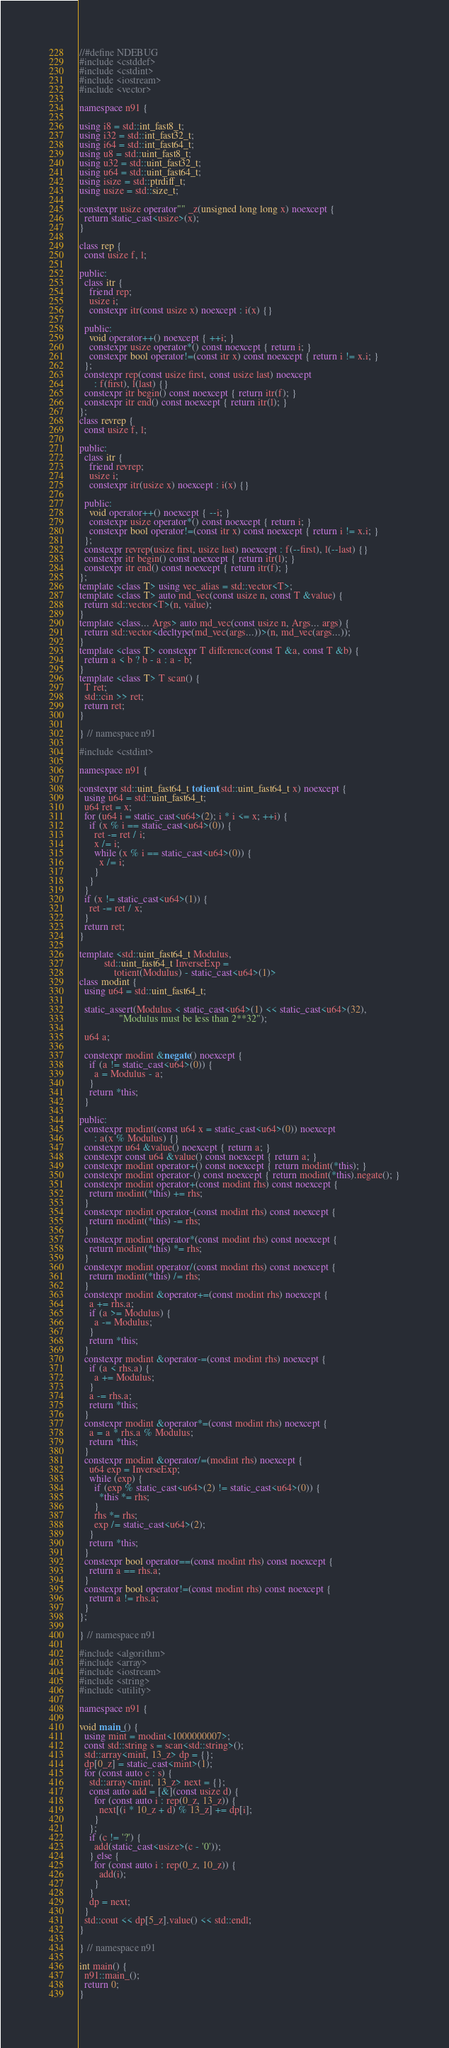Convert code to text. <code><loc_0><loc_0><loc_500><loc_500><_C++_>//#define NDEBUG
#include <cstddef>
#include <cstdint>
#include <iostream>
#include <vector>

namespace n91 {

using i8 = std::int_fast8_t;
using i32 = std::int_fast32_t;
using i64 = std::int_fast64_t;
using u8 = std::uint_fast8_t;
using u32 = std::uint_fast32_t;
using u64 = std::uint_fast64_t;
using isize = std::ptrdiff_t;
using usize = std::size_t;

constexpr usize operator"" _z(unsigned long long x) noexcept {
  return static_cast<usize>(x);
}

class rep {
  const usize f, l;

public:
  class itr {
    friend rep;
    usize i;
    constexpr itr(const usize x) noexcept : i(x) {}

  public:
    void operator++() noexcept { ++i; }
    constexpr usize operator*() const noexcept { return i; }
    constexpr bool operator!=(const itr x) const noexcept { return i != x.i; }
  };
  constexpr rep(const usize first, const usize last) noexcept
      : f(first), l(last) {}
  constexpr itr begin() const noexcept { return itr(f); }
  constexpr itr end() const noexcept { return itr(l); }
};
class revrep {
  const usize f, l;

public:
  class itr {
    friend revrep;
    usize i;
    constexpr itr(usize x) noexcept : i(x) {}

  public:
    void operator++() noexcept { --i; }
    constexpr usize operator*() const noexcept { return i; }
    constexpr bool operator!=(const itr x) const noexcept { return i != x.i; }
  };
  constexpr revrep(usize first, usize last) noexcept : f(--first), l(--last) {}
  constexpr itr begin() const noexcept { return itr(l); }
  constexpr itr end() const noexcept { return itr(f); }
};
template <class T> using vec_alias = std::vector<T>;
template <class T> auto md_vec(const usize n, const T &value) {
  return std::vector<T>(n, value);
}
template <class... Args> auto md_vec(const usize n, Args... args) {
  return std::vector<decltype(md_vec(args...))>(n, md_vec(args...));
}
template <class T> constexpr T difference(const T &a, const T &b) {
  return a < b ? b - a : a - b;
}
template <class T> T scan() {
  T ret;
  std::cin >> ret;
  return ret;
}

} // namespace n91

#include <cstdint>

namespace n91 {

constexpr std::uint_fast64_t totient(std::uint_fast64_t x) noexcept {
  using u64 = std::uint_fast64_t;
  u64 ret = x;
  for (u64 i = static_cast<u64>(2); i * i <= x; ++i) {
    if (x % i == static_cast<u64>(0)) {
      ret -= ret / i;
      x /= i;
      while (x % i == static_cast<u64>(0)) {
        x /= i;
      }
    }
  }
  if (x != static_cast<u64>(1)) {
    ret -= ret / x;
  }
  return ret;
}

template <std::uint_fast64_t Modulus,
          std::uint_fast64_t InverseExp =
              totient(Modulus) - static_cast<u64>(1)>
class modint {
  using u64 = std::uint_fast64_t;

  static_assert(Modulus < static_cast<u64>(1) << static_cast<u64>(32),
                "Modulus must be less than 2**32");

  u64 a;

  constexpr modint &negate() noexcept {
    if (a != static_cast<u64>(0)) {
      a = Modulus - a;
    }
    return *this;
  }

public:
  constexpr modint(const u64 x = static_cast<u64>(0)) noexcept
      : a(x % Modulus) {}
  constexpr u64 &value() noexcept { return a; }
  constexpr const u64 &value() const noexcept { return a; }
  constexpr modint operator+() const noexcept { return modint(*this); }
  constexpr modint operator-() const noexcept { return modint(*this).negate(); }
  constexpr modint operator+(const modint rhs) const noexcept {
    return modint(*this) += rhs;
  }
  constexpr modint operator-(const modint rhs) const noexcept {
    return modint(*this) -= rhs;
  }
  constexpr modint operator*(const modint rhs) const noexcept {
    return modint(*this) *= rhs;
  }
  constexpr modint operator/(const modint rhs) const noexcept {
    return modint(*this) /= rhs;
  }
  constexpr modint &operator+=(const modint rhs) noexcept {
    a += rhs.a;
    if (a >= Modulus) {
      a -= Modulus;
    }
    return *this;
  }
  constexpr modint &operator-=(const modint rhs) noexcept {
    if (a < rhs.a) {
      a += Modulus;
    }
    a -= rhs.a;
    return *this;
  }
  constexpr modint &operator*=(const modint rhs) noexcept {
    a = a * rhs.a % Modulus;
    return *this;
  }
  constexpr modint &operator/=(modint rhs) noexcept {
    u64 exp = InverseExp;
    while (exp) {
      if (exp % static_cast<u64>(2) != static_cast<u64>(0)) {
        *this *= rhs;
      }
      rhs *= rhs;
      exp /= static_cast<u64>(2);
    }
    return *this;
  }
  constexpr bool operator==(const modint rhs) const noexcept {
    return a == rhs.a;
  }
  constexpr bool operator!=(const modint rhs) const noexcept {
    return a != rhs.a;
  }
};

} // namespace n91

#include <algorithm>
#include <array>
#include <iostream>
#include <string>
#include <utility>

namespace n91 {

void main_() {
  using mint = modint<1000000007>;
  const std::string s = scan<std::string>();
  std::array<mint, 13_z> dp = {};
  dp[0_z] = static_cast<mint>(1);
  for (const auto c : s) {
    std::array<mint, 13_z> next = {};
    const auto add = [&](const usize d) {
      for (const auto i : rep(0_z, 13_z)) {
        next[(i * 10_z + d) % 13_z] += dp[i];
      }
    };
    if (c != '?') {
      add(static_cast<usize>(c - '0'));
    } else {
      for (const auto i : rep(0_z, 10_z)) {
        add(i);
      }
    }
    dp = next;
  }
  std::cout << dp[5_z].value() << std::endl;
}

} // namespace n91

int main() {
  n91::main_();
  return 0;
}
</code> 